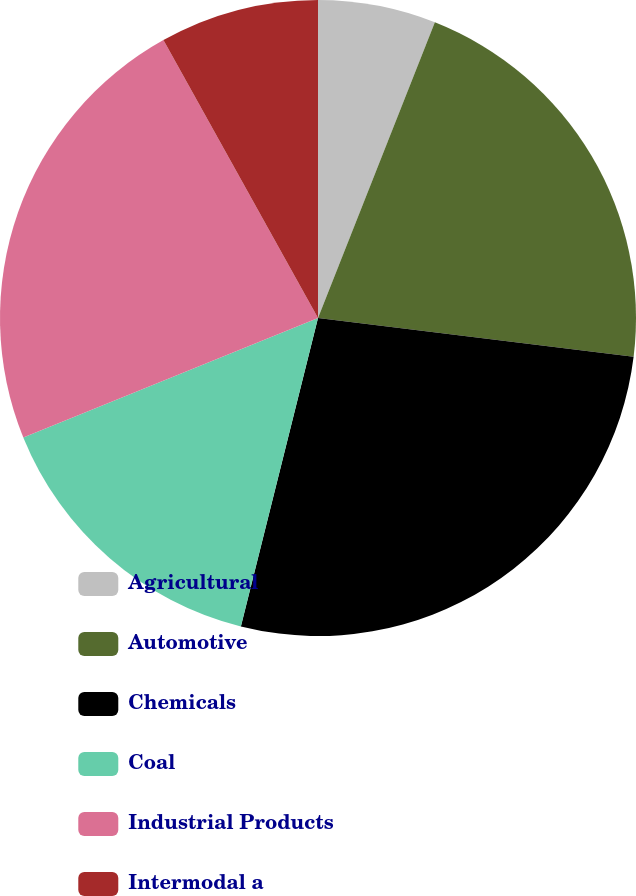Convert chart. <chart><loc_0><loc_0><loc_500><loc_500><pie_chart><fcel>Agricultural<fcel>Automotive<fcel>Chemicals<fcel>Coal<fcel>Industrial Products<fcel>Intermodal a<nl><fcel>5.99%<fcel>20.96%<fcel>26.95%<fcel>14.97%<fcel>23.05%<fcel>8.08%<nl></chart> 